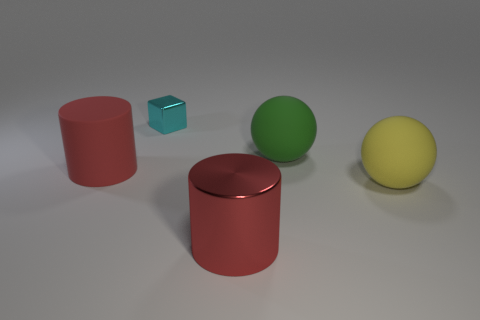Add 3 small blue things. How many objects exist? 8 Subtract all blocks. How many objects are left? 4 Subtract all cyan blocks. Subtract all large cyan shiny spheres. How many objects are left? 4 Add 1 red matte objects. How many red matte objects are left? 2 Add 4 tiny purple shiny blocks. How many tiny purple shiny blocks exist? 4 Subtract 0 brown cylinders. How many objects are left? 5 